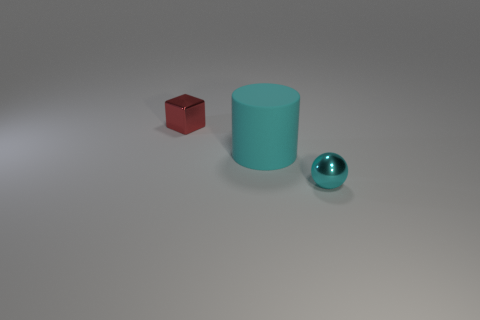Is there any other thing that has the same material as the large cylinder?
Offer a very short reply. No. There is a metal object left of the tiny cyan metallic ball; what is its size?
Make the answer very short. Small. There is a tiny thing in front of the tiny red metallic block; is its color the same as the large rubber thing?
Offer a terse response. Yes. How many objects are shiny objects that are behind the rubber object or things to the left of the cyan matte thing?
Your answer should be very brief. 1. How many gray objects are either tiny shiny balls or big shiny cylinders?
Keep it short and to the point. 0. What is the object that is on the right side of the red block and behind the metallic sphere made of?
Your answer should be compact. Rubber. Does the cyan cylinder have the same material as the block?
Your answer should be compact. No. How many red objects are the same size as the ball?
Make the answer very short. 1. Are there the same number of cyan metallic objects that are left of the red metal block and small cyan metal things?
Your answer should be compact. No. What number of things are both in front of the big cylinder and left of the big cyan object?
Offer a terse response. 0. 